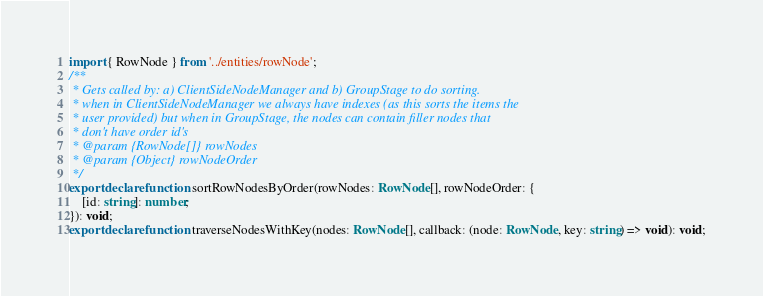Convert code to text. <code><loc_0><loc_0><loc_500><loc_500><_TypeScript_>import { RowNode } from '../entities/rowNode';
/**
 * Gets called by: a) ClientSideNodeManager and b) GroupStage to do sorting.
 * when in ClientSideNodeManager we always have indexes (as this sorts the items the
 * user provided) but when in GroupStage, the nodes can contain filler nodes that
 * don't have order id's
 * @param {RowNode[]} rowNodes
 * @param {Object} rowNodeOrder
 */
export declare function sortRowNodesByOrder(rowNodes: RowNode[], rowNodeOrder: {
    [id: string]: number;
}): void;
export declare function traverseNodesWithKey(nodes: RowNode[], callback: (node: RowNode, key: string) => void): void;
</code> 